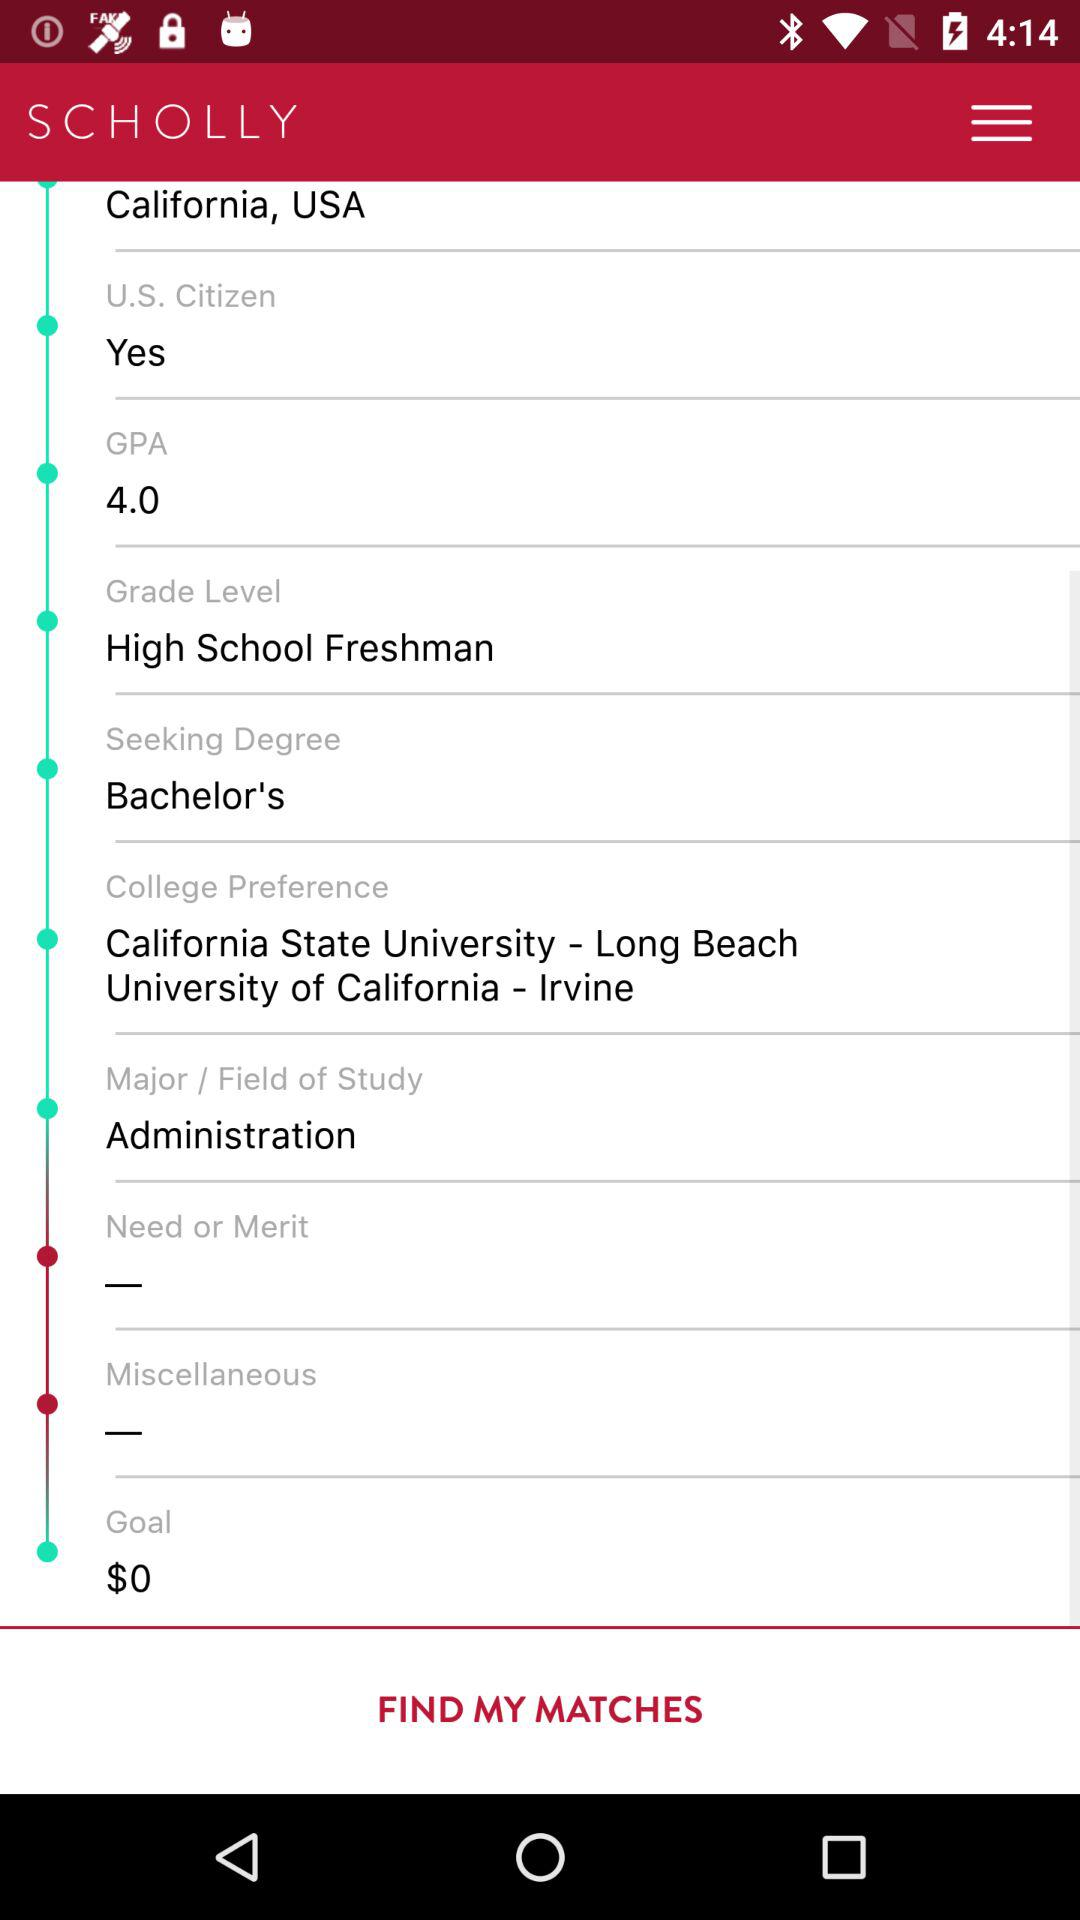How many of the inputs have a red circle next to them?
Answer the question using a single word or phrase. 2 